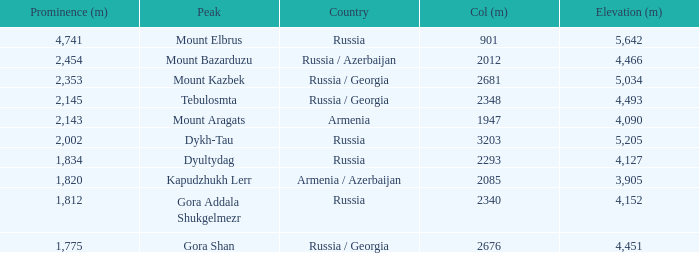What is the Col (m) of Peak Mount Aragats with an Elevation (m) larger than 3,905 and Prominence smaller than 2,143? None. 